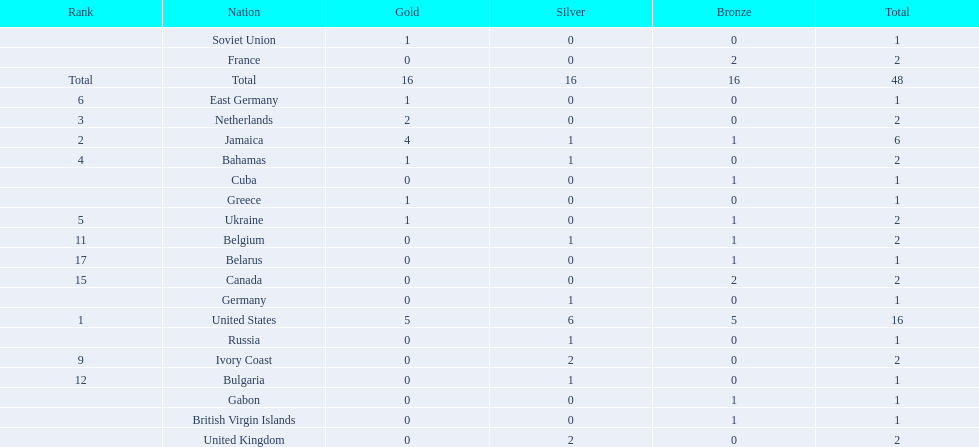Which countries won at least 3 silver medals? United States. 